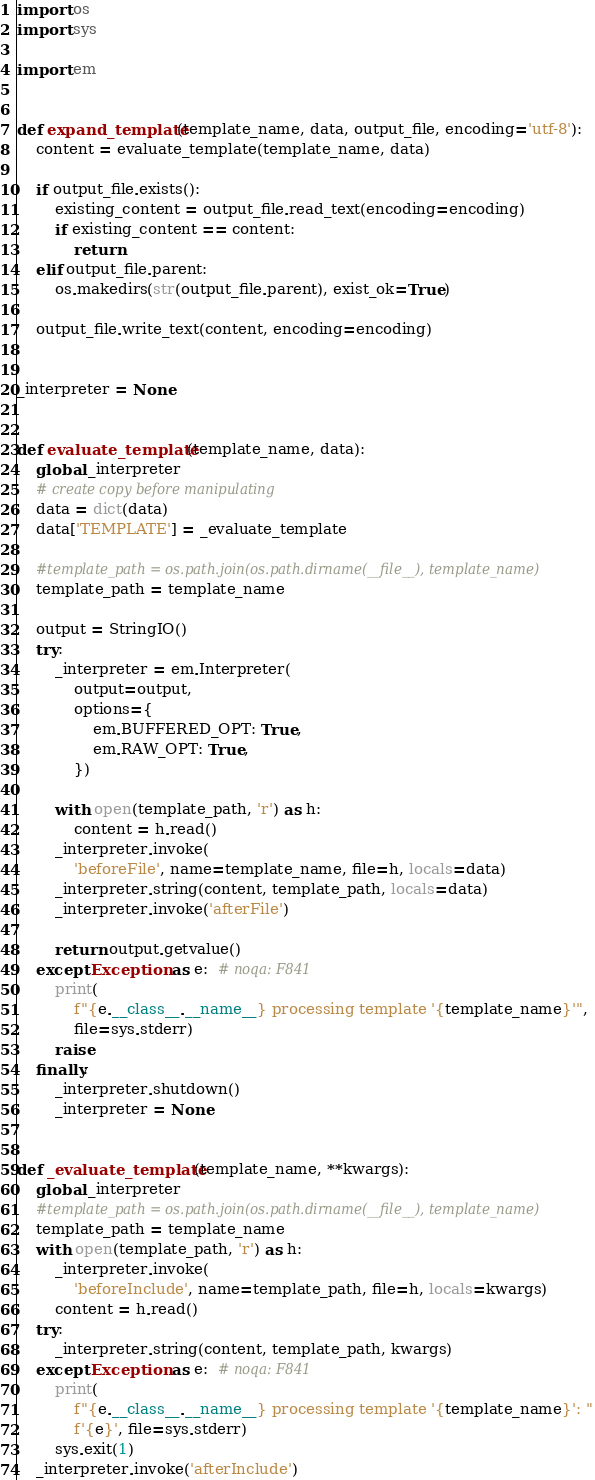<code> <loc_0><loc_0><loc_500><loc_500><_Python_>import os
import sys

import em


def expand_template(template_name, data, output_file, encoding='utf-8'):
    content = evaluate_template(template_name, data)

    if output_file.exists():
        existing_content = output_file.read_text(encoding=encoding)
        if existing_content == content:
            return
    elif output_file.parent:
        os.makedirs(str(output_file.parent), exist_ok=True)

    output_file.write_text(content, encoding=encoding)


_interpreter = None


def evaluate_template(template_name, data):
    global _interpreter
    # create copy before manipulating
    data = dict(data)
    data['TEMPLATE'] = _evaluate_template

    #template_path = os.path.join(os.path.dirname(__file__), template_name)
    template_path = template_name

    output = StringIO()
    try:
        _interpreter = em.Interpreter(
            output=output,
            options={
                em.BUFFERED_OPT: True,
                em.RAW_OPT: True,
            })

        with open(template_path, 'r') as h:
            content = h.read()
        _interpreter.invoke(
            'beforeFile', name=template_name, file=h, locals=data)
        _interpreter.string(content, template_path, locals=data)
        _interpreter.invoke('afterFile')

        return output.getvalue()
    except Exception as e:  # noqa: F841
        print(
            f"{e.__class__.__name__} processing template '{template_name}'",
            file=sys.stderr)
        raise
    finally:
        _interpreter.shutdown()
        _interpreter = None


def _evaluate_template(template_name, **kwargs):
    global _interpreter
    #template_path = os.path.join(os.path.dirname(__file__), template_name)
    template_path = template_name
    with open(template_path, 'r') as h:
        _interpreter.invoke(
            'beforeInclude', name=template_path, file=h, locals=kwargs)
        content = h.read()
    try:
        _interpreter.string(content, template_path, kwargs)
    except Exception as e:  # noqa: F841
        print(
            f"{e.__class__.__name__} processing template '{template_name}': "
            f'{e}', file=sys.stderr)
        sys.exit(1)
    _interpreter.invoke('afterInclude')</code> 